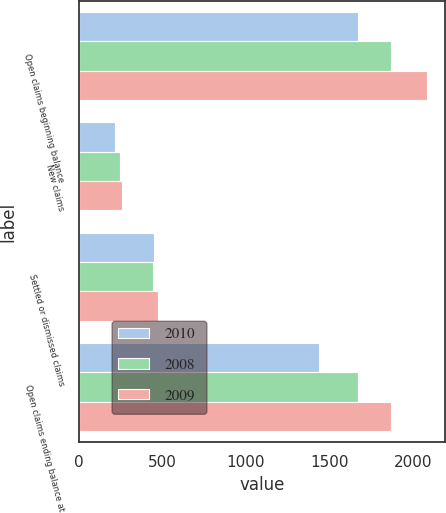Convert chart to OTSL. <chart><loc_0><loc_0><loc_500><loc_500><stacked_bar_chart><ecel><fcel>Open claims beginning balance<fcel>New claims<fcel>Settled or dismissed claims<fcel>Open claims ending balance at<nl><fcel>2010<fcel>1670<fcel>216<fcel>449<fcel>1437<nl><fcel>2008<fcel>1867<fcel>249<fcel>446<fcel>1670<nl><fcel>2009<fcel>2086<fcel>256<fcel>475<fcel>1867<nl></chart> 